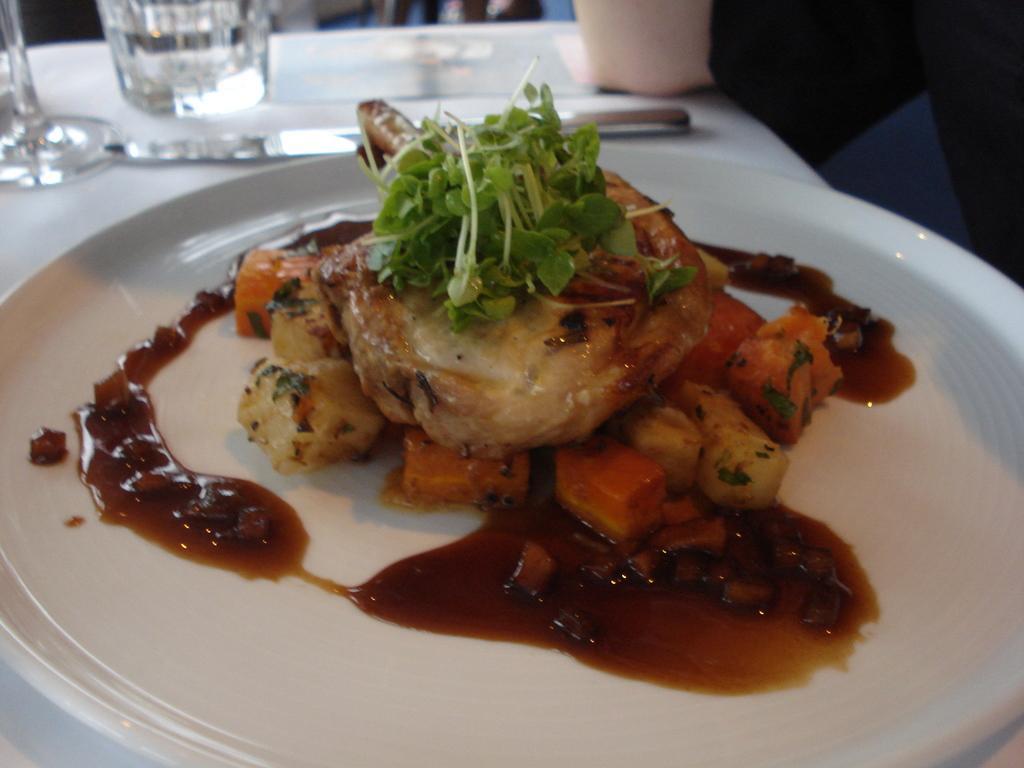Could you give a brief overview of what you see in this image? In the picture I can see food items in a plate. In the background I can see glasses and some other objects on a white color table. The background of the image is blurred. 